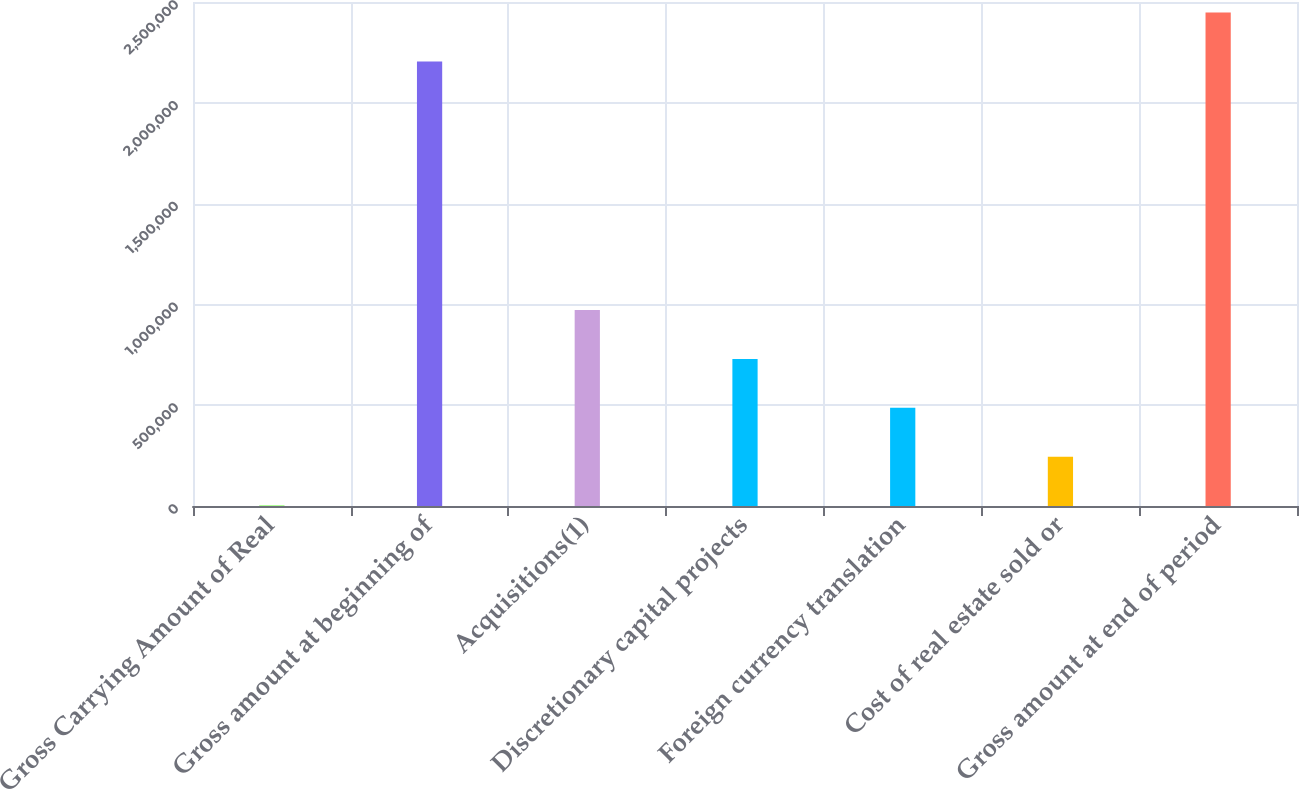Convert chart to OTSL. <chart><loc_0><loc_0><loc_500><loc_500><bar_chart><fcel>Gross Carrying Amount of Real<fcel>Gross amount at beginning of<fcel>Acquisitions(1)<fcel>Discretionary capital projects<fcel>Foreign currency translation<fcel>Cost of real estate sold or<fcel>Gross amount at end of period<nl><fcel>2016<fcel>2.20499e+06<fcel>972226<fcel>729673<fcel>487121<fcel>244568<fcel>2.44754e+06<nl></chart> 